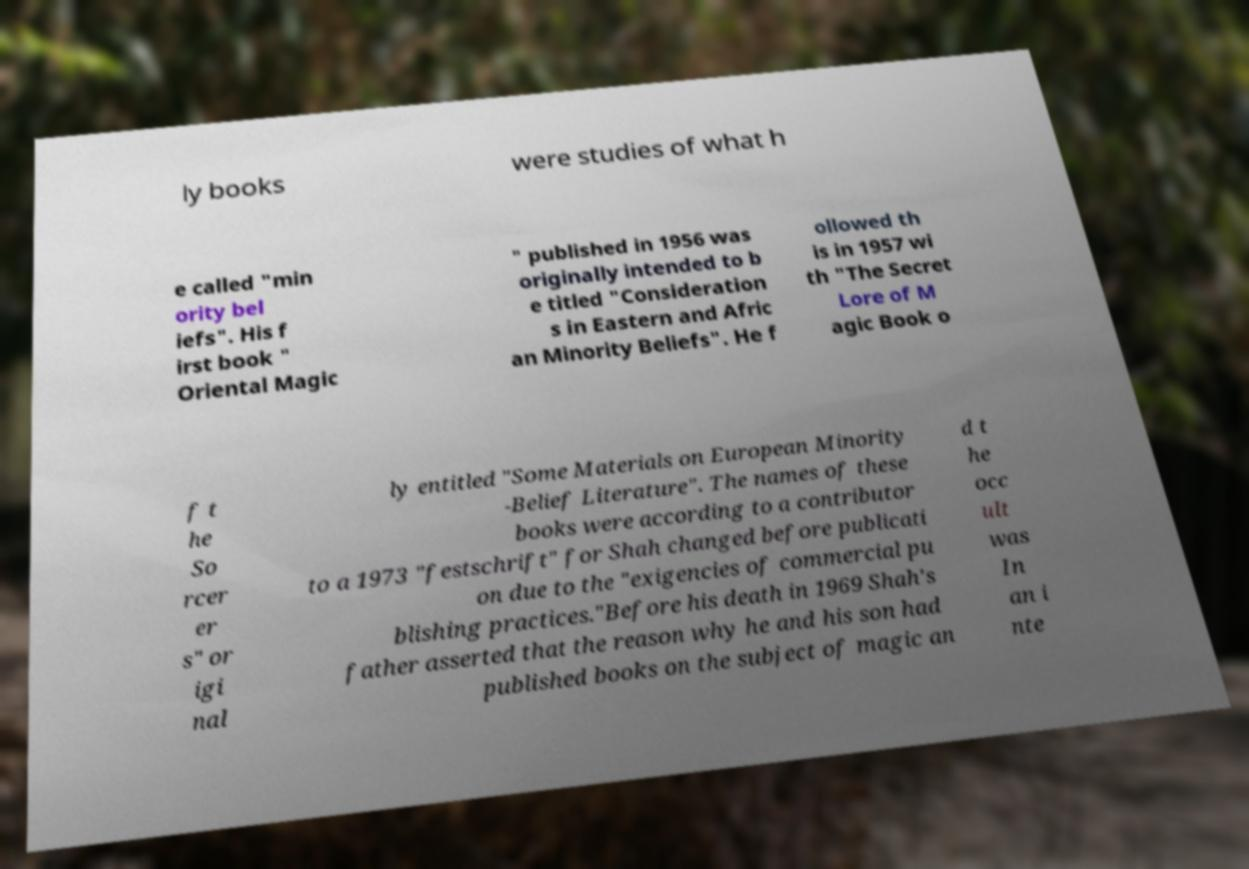What messages or text are displayed in this image? I need them in a readable, typed format. ly books were studies of what h e called "min ority bel iefs". His f irst book " Oriental Magic " published in 1956 was originally intended to b e titled "Consideration s in Eastern and Afric an Minority Beliefs". He f ollowed th is in 1957 wi th "The Secret Lore of M agic Book o f t he So rcer er s" or igi nal ly entitled "Some Materials on European Minority -Belief Literature". The names of these books were according to a contributor to a 1973 "festschrift" for Shah changed before publicati on due to the "exigencies of commercial pu blishing practices."Before his death in 1969 Shah's father asserted that the reason why he and his son had published books on the subject of magic an d t he occ ult was In an i nte 